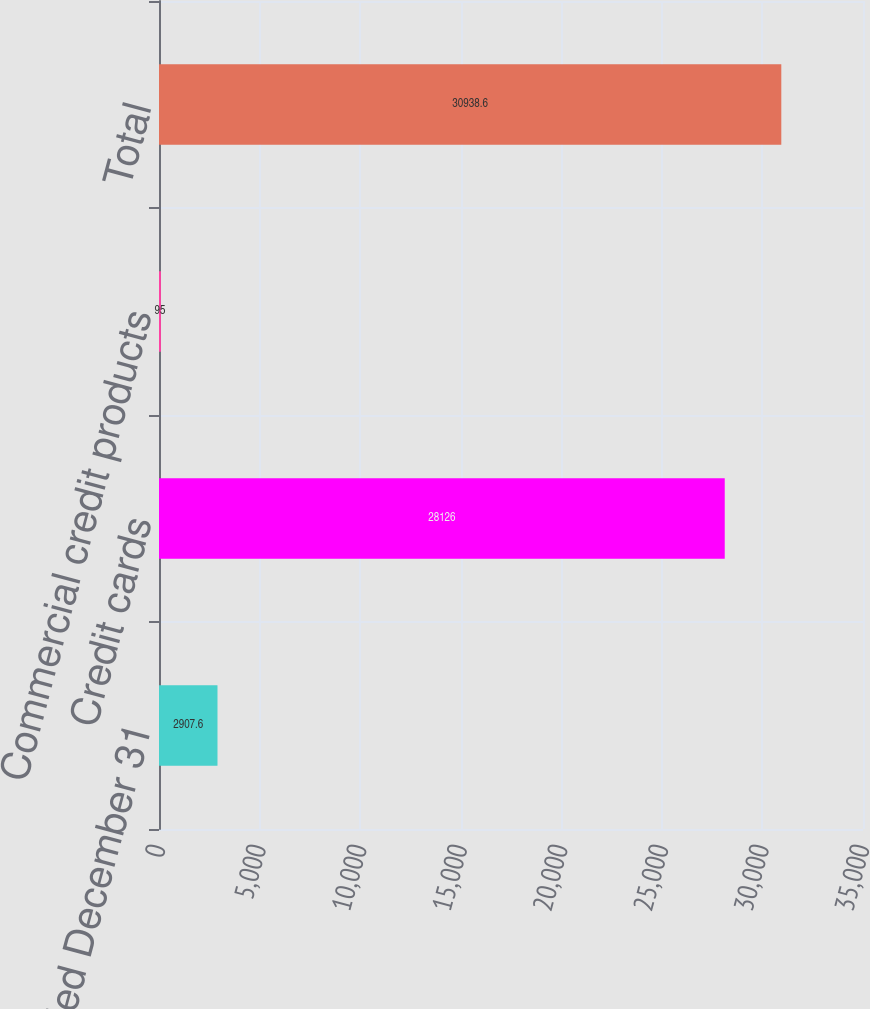Convert chart to OTSL. <chart><loc_0><loc_0><loc_500><loc_500><bar_chart><fcel>Years ended December 31<fcel>Credit cards<fcel>Commercial credit products<fcel>Total<nl><fcel>2907.6<fcel>28126<fcel>95<fcel>30938.6<nl></chart> 